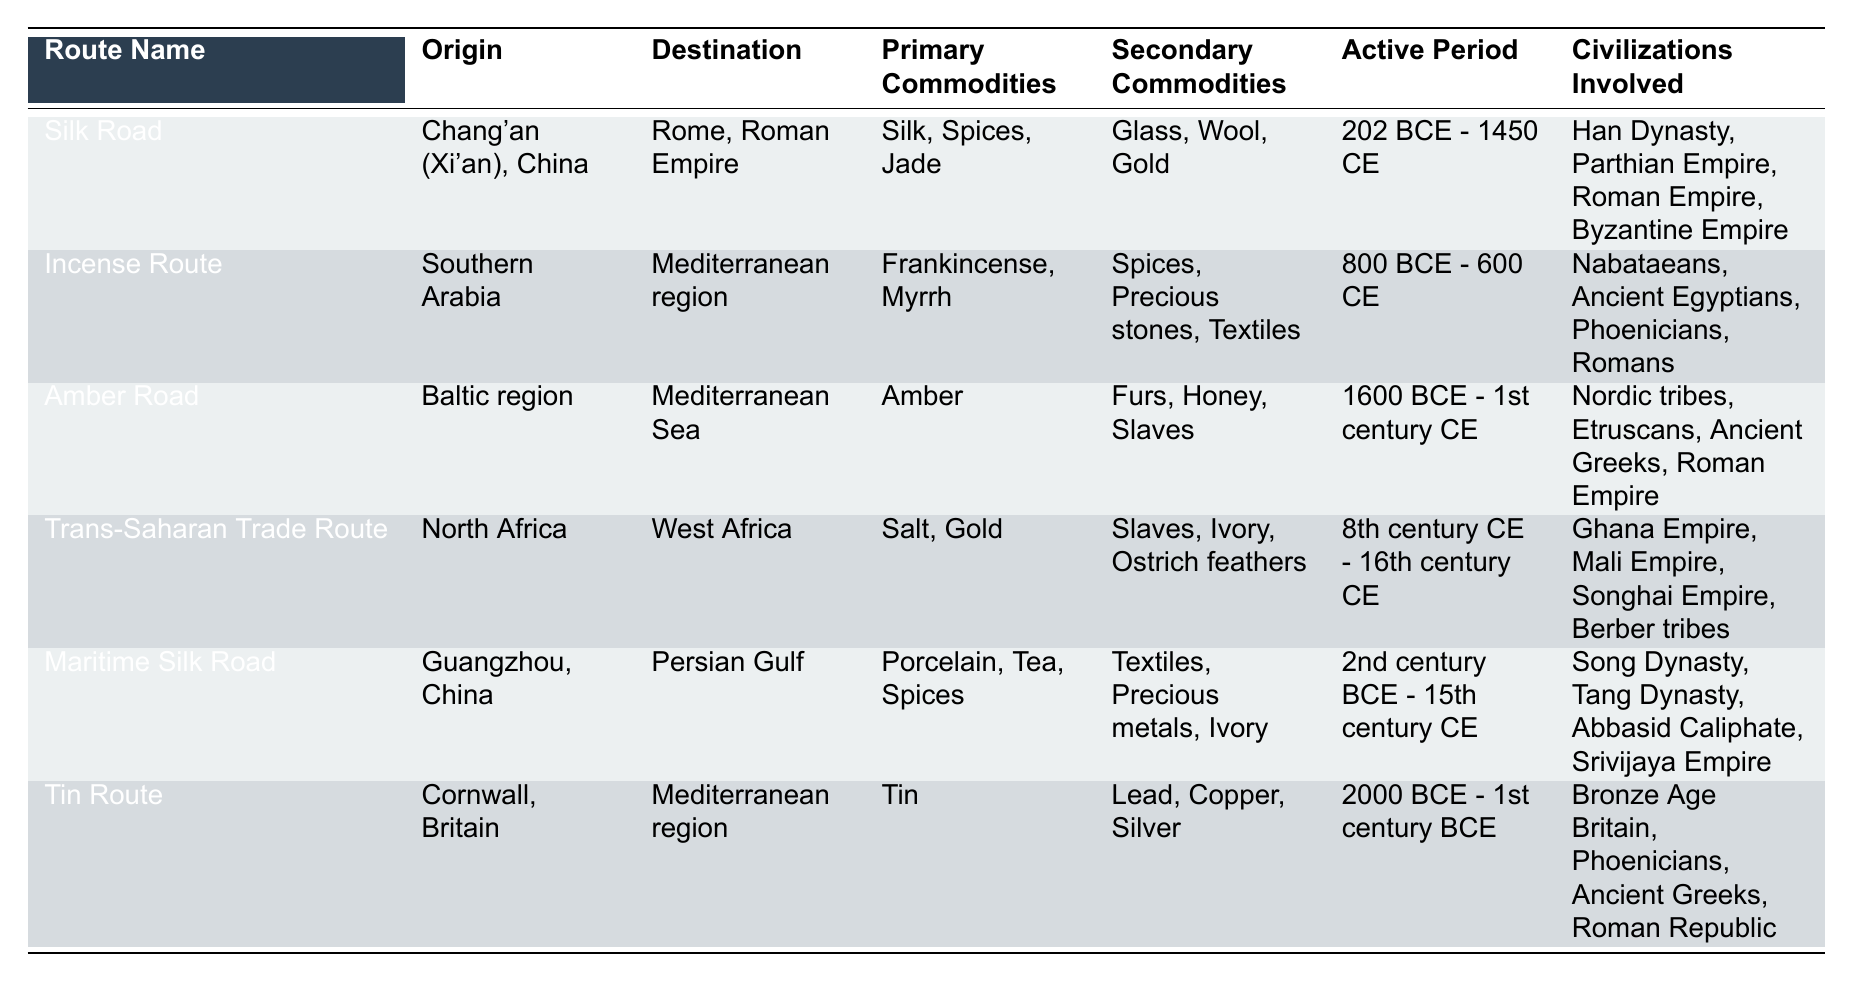What is the primary commodity exchanged along the Silk Road? Referring to the table, the primary commodities listed for the Silk Road include Silk, Spices, and Jade.
Answer: Silk, Spices, Jade Which two civilizations were involved in the Trans-Saharan Trade Route? The table shows the civilizations involved in the Trans-Saharan Trade Route are Ghana Empire, Mali Empire, Songhai Empire, and Berber tribes. Two of these are Ghana Empire and Mali Empire.
Answer: Ghana Empire, Mali Empire When was the Maritime Silk Road active? Looking at the specific row for the Maritime Silk Road, it states the active period as 2nd century BCE - 15th century CE.
Answer: 2nd century BCE - 15th century CE Which route involved the exchange of both Salt and Gold? By scanning the table, it is clear that the Trans-Saharan Trade Route lists Salt and Gold as its primary commodities.
Answer: Trans-Saharan Trade Route Are spices traded on the Incense Route? The table indicates that spices are listed among the secondary commodities on the Incense Route. Therefore, the answer is yes.
Answer: Yes How many trade routes involved the Roman Empire? Analyzing the data, the Silk Road, Amber Road, and Incense Route all include the Roman Empire as part of the civilizations involved. This counts to three routes.
Answer: 3 What is the difference in active periods between the Amber Road and the Tin Route? The Amber Road was active from 1600 BCE to the 1st century CE, and the Tin Route was active from 2000 BCE to the 1st century BCE. The difference is 400 years, as the Tin Route starts earlier than the Amber Road.
Answer: 400 years Which civilization was only involved in the Amber Road route? The table lists Nordic tribes, Etruscans, Ancient Greeks, and Roman Empire under the Amber Road. Among these, the Nordic tribes are specifically related to the Baltic region, suggesting they were primarily involved in this route.
Answer: Nordic tribes Identify a primary commodity common to both the Maritime Silk Road and the Silk Road. Upon inspecting the primary commodities for both routes, "Spices" appears on the lists for both the Maritime Silk Road and the Silk Road.
Answer: Spices What are the secondary commodities of the Trans-Saharan Trade Route? From the table, the secondary commodities for the Trans-Saharan Trade Route are listed as Slaves, Ivory, and Ostrich feathers.
Answer: Slaves, Ivory, Ostrich feathers Is it true that the Incense Route had a shorter active period than the Silk Road? The Silk Road was active from 202 BCE to 1450 CE, while the Incense Route was active from 800 BCE to 600 CE. The Silk Road was active for 1652 years, and the Incense Route was active for 1400 years, thus it is true that the Incense Route had a shorter active period.
Answer: True 